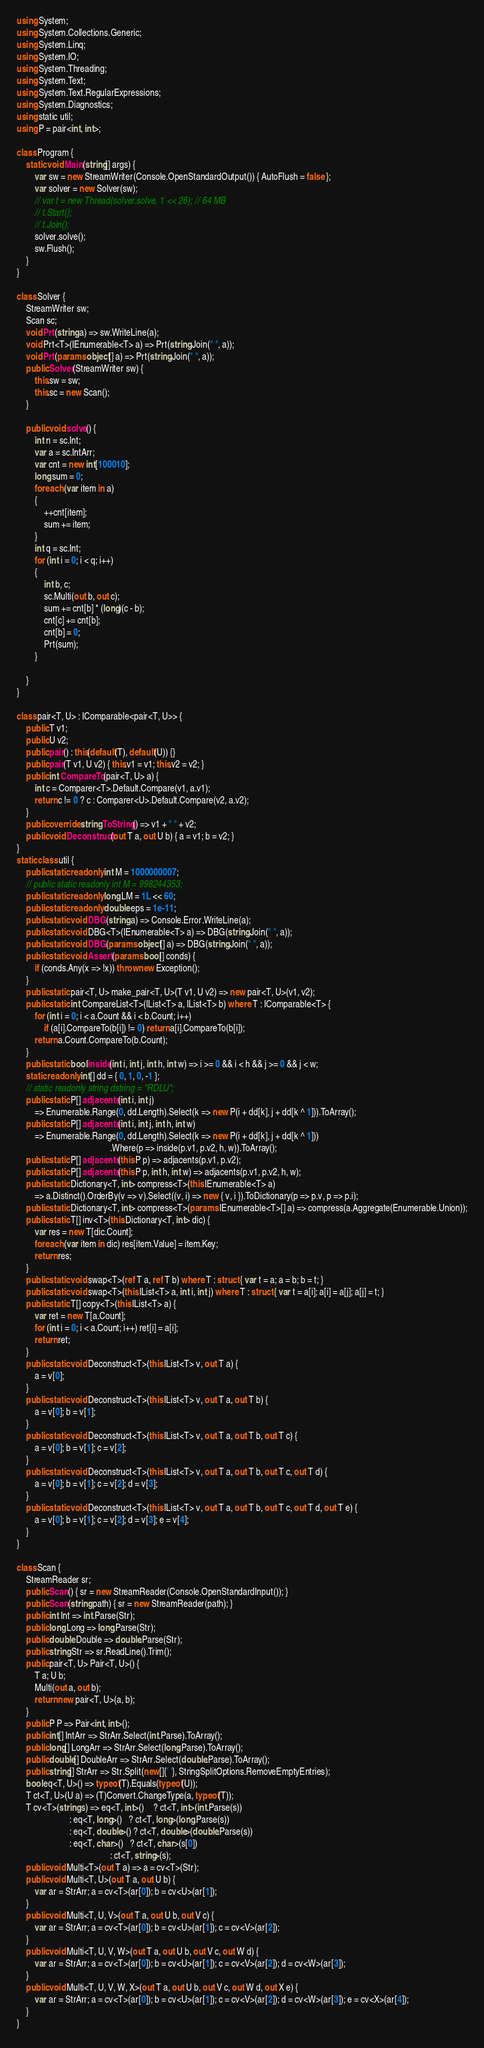Convert code to text. <code><loc_0><loc_0><loc_500><loc_500><_C#_>using System;
using System.Collections.Generic;
using System.Linq;
using System.IO;
using System.Threading;
using System.Text;
using System.Text.RegularExpressions;
using System.Diagnostics;
using static util;
using P = pair<int, int>;

class Program {
    static void Main(string[] args) {
        var sw = new StreamWriter(Console.OpenStandardOutput()) { AutoFlush = false };
        var solver = new Solver(sw);
        // var t = new Thread(solver.solve, 1 << 26); // 64 MB
        // t.Start();
        // t.Join();
        solver.solve();
        sw.Flush();
    }
}

class Solver {
    StreamWriter sw;
    Scan sc;
    void Prt(string a) => sw.WriteLine(a);
    void Prt<T>(IEnumerable<T> a) => Prt(string.Join(" ", a));
    void Prt(params object[] a) => Prt(string.Join(" ", a));
    public Solver(StreamWriter sw) {
        this.sw = sw;
        this.sc = new Scan();
    }

    public void solve() {
        int n = sc.Int;
        var a = sc.IntArr;
        var cnt = new int[100010];
        long sum = 0;
        foreach (var item in a)
        {
            ++cnt[item];
            sum += item;
        }
        int q = sc.Int;
        for (int i = 0; i < q; i++)
        {
            int b, c;
            sc.Multi(out b, out c);
            sum += cnt[b] * (long)(c - b);
            cnt[c] += cnt[b];
            cnt[b] = 0;
            Prt(sum);
        }

    }
}

class pair<T, U> : IComparable<pair<T, U>> {
    public T v1;
    public U v2;
    public pair() : this(default(T), default(U)) {}
    public pair(T v1, U v2) { this.v1 = v1; this.v2 = v2; }
    public int CompareTo(pair<T, U> a) {
        int c = Comparer<T>.Default.Compare(v1, a.v1);
        return c != 0 ? c : Comparer<U>.Default.Compare(v2, a.v2);
    }
    public override string ToString() => v1 + " " + v2;
    public void Deconstruct(out T a, out U b) { a = v1; b = v2; }
}
static class util {
    public static readonly int M = 1000000007;
    // public static readonly int M = 998244353;
    public static readonly long LM = 1L << 60;
    public static readonly double eps = 1e-11;
    public static void DBG(string a) => Console.Error.WriteLine(a);
    public static void DBG<T>(IEnumerable<T> a) => DBG(string.Join(" ", a));
    public static void DBG(params object[] a) => DBG(string.Join(" ", a));
    public static void Assert(params bool[] conds) {
        if (conds.Any(x => !x)) throw new Exception();
    }
    public static pair<T, U> make_pair<T, U>(T v1, U v2) => new pair<T, U>(v1, v2);
    public static int CompareList<T>(IList<T> a, IList<T> b) where T : IComparable<T> {
        for (int i = 0; i < a.Count && i < b.Count; i++)
            if (a[i].CompareTo(b[i]) != 0) return a[i].CompareTo(b[i]);
        return a.Count.CompareTo(b.Count);
    }
    public static bool inside(int i, int j, int h, int w) => i >= 0 && i < h && j >= 0 && j < w;
    static readonly int[] dd = { 0, 1, 0, -1 };
    // static readonly string dstring = "RDLU";
    public static P[] adjacents(int i, int j)
        => Enumerable.Range(0, dd.Length).Select(k => new P(i + dd[k], j + dd[k ^ 1])).ToArray();
    public static P[] adjacents(int i, int j, int h, int w)
        => Enumerable.Range(0, dd.Length).Select(k => new P(i + dd[k], j + dd[k ^ 1]))
                                         .Where(p => inside(p.v1, p.v2, h, w)).ToArray();
    public static P[] adjacents(this P p) => adjacents(p.v1, p.v2);
    public static P[] adjacents(this P p, int h, int w) => adjacents(p.v1, p.v2, h, w);
    public static Dictionary<T, int> compress<T>(this IEnumerable<T> a)
        => a.Distinct().OrderBy(v => v).Select((v, i) => new { v, i }).ToDictionary(p => p.v, p => p.i);
    public static Dictionary<T, int> compress<T>(params IEnumerable<T>[] a) => compress(a.Aggregate(Enumerable.Union));
    public static T[] inv<T>(this Dictionary<T, int> dic) {
        var res = new T[dic.Count];
        foreach (var item in dic) res[item.Value] = item.Key;
        return res;
    }
    public static void swap<T>(ref T a, ref T b) where T : struct { var t = a; a = b; b = t; }
    public static void swap<T>(this IList<T> a, int i, int j) where T : struct { var t = a[i]; a[i] = a[j]; a[j] = t; }
    public static T[] copy<T>(this IList<T> a) {
        var ret = new T[a.Count];
        for (int i = 0; i < a.Count; i++) ret[i] = a[i];
        return ret;
    }
    public static void Deconstruct<T>(this IList<T> v, out T a) {
        a = v[0];
    }
    public static void Deconstruct<T>(this IList<T> v, out T a, out T b) {
        a = v[0]; b = v[1];
    }
    public static void Deconstruct<T>(this IList<T> v, out T a, out T b, out T c) {
        a = v[0]; b = v[1]; c = v[2];
    }
    public static void Deconstruct<T>(this IList<T> v, out T a, out T b, out T c, out T d) {
        a = v[0]; b = v[1]; c = v[2]; d = v[3];
    }
    public static void Deconstruct<T>(this IList<T> v, out T a, out T b, out T c, out T d, out T e) {
        a = v[0]; b = v[1]; c = v[2]; d = v[3]; e = v[4];
    }
}

class Scan {
    StreamReader sr;
    public Scan() { sr = new StreamReader(Console.OpenStandardInput()); }
    public Scan(string path) { sr = new StreamReader(path); }
    public int Int => int.Parse(Str);
    public long Long => long.Parse(Str);
    public double Double => double.Parse(Str);
    public string Str => sr.ReadLine().Trim();
    public pair<T, U> Pair<T, U>() {
        T a; U b;
        Multi(out a, out b);
        return new pair<T, U>(a, b);
    }
    public P P => Pair<int, int>();
    public int[] IntArr => StrArr.Select(int.Parse).ToArray();
    public long[] LongArr => StrArr.Select(long.Parse).ToArray();
    public double[] DoubleArr => StrArr.Select(double.Parse).ToArray();
    public string[] StrArr => Str.Split(new[]{' '}, StringSplitOptions.RemoveEmptyEntries);
    bool eq<T, U>() => typeof(T).Equals(typeof(U));
    T ct<T, U>(U a) => (T)Convert.ChangeType(a, typeof(T));
    T cv<T>(string s) => eq<T, int>()    ? ct<T, int>(int.Parse(s))
                       : eq<T, long>()   ? ct<T, long>(long.Parse(s))
                       : eq<T, double>() ? ct<T, double>(double.Parse(s))
                       : eq<T, char>()   ? ct<T, char>(s[0])
                                         : ct<T, string>(s);
    public void Multi<T>(out T a) => a = cv<T>(Str);
    public void Multi<T, U>(out T a, out U b) {
        var ar = StrArr; a = cv<T>(ar[0]); b = cv<U>(ar[1]);
    }
    public void Multi<T, U, V>(out T a, out U b, out V c) {
        var ar = StrArr; a = cv<T>(ar[0]); b = cv<U>(ar[1]); c = cv<V>(ar[2]);
    }
    public void Multi<T, U, V, W>(out T a, out U b, out V c, out W d) {
        var ar = StrArr; a = cv<T>(ar[0]); b = cv<U>(ar[1]); c = cv<V>(ar[2]); d = cv<W>(ar[3]);
    }
    public void Multi<T, U, V, W, X>(out T a, out U b, out V c, out W d, out X e) {
        var ar = StrArr; a = cv<T>(ar[0]); b = cv<U>(ar[1]); c = cv<V>(ar[2]); d = cv<W>(ar[3]); e = cv<X>(ar[4]);
    }
}
</code> 